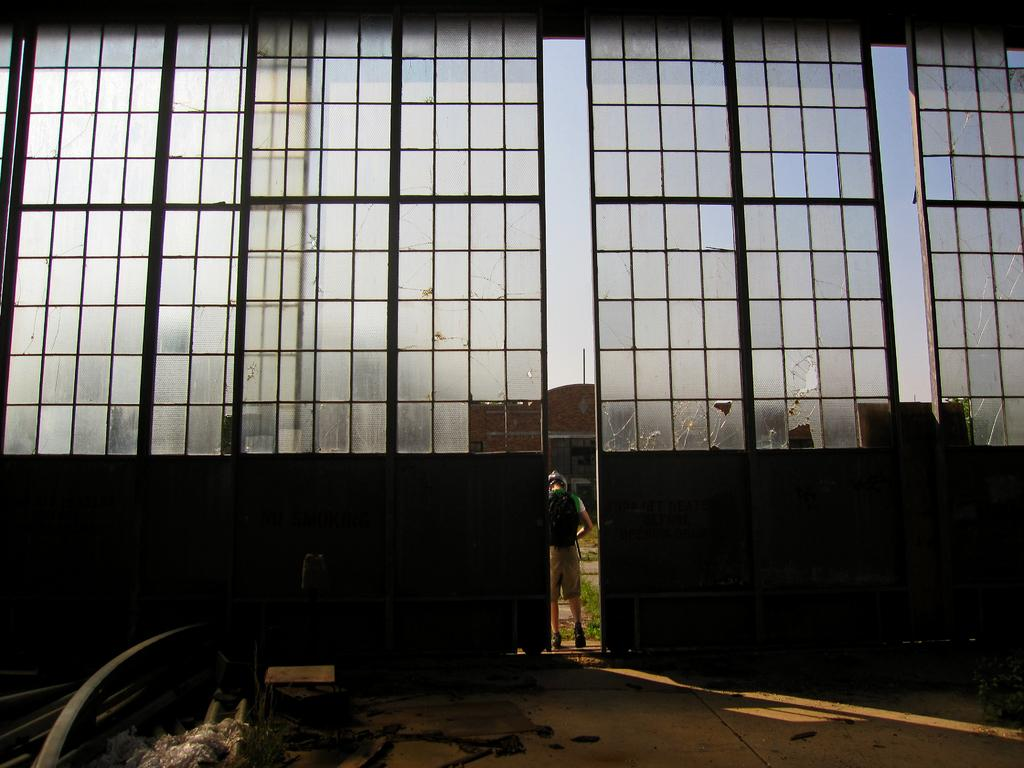What type of material is used for the windows in the image? There are glass windows in the image. Can you describe the person in the image? There is a person in the image, and they are wearing a bag. What type of structure is present in the image? There is a building in the image. What type of natural environment is visible in the image? There is grass in the image. What is visible in the background of the image? The sky is visible in the image. What else can be seen in the image besides the person and the building? There are objects in the image. Can you hear the bells ringing in the image? There are no bells present in the image, so it is not possible to hear them ringing. Is there a pig visible in the image? There is no pig present in the image. What type of vehicle is passing by in the image? There is no vehicle present in the image. 